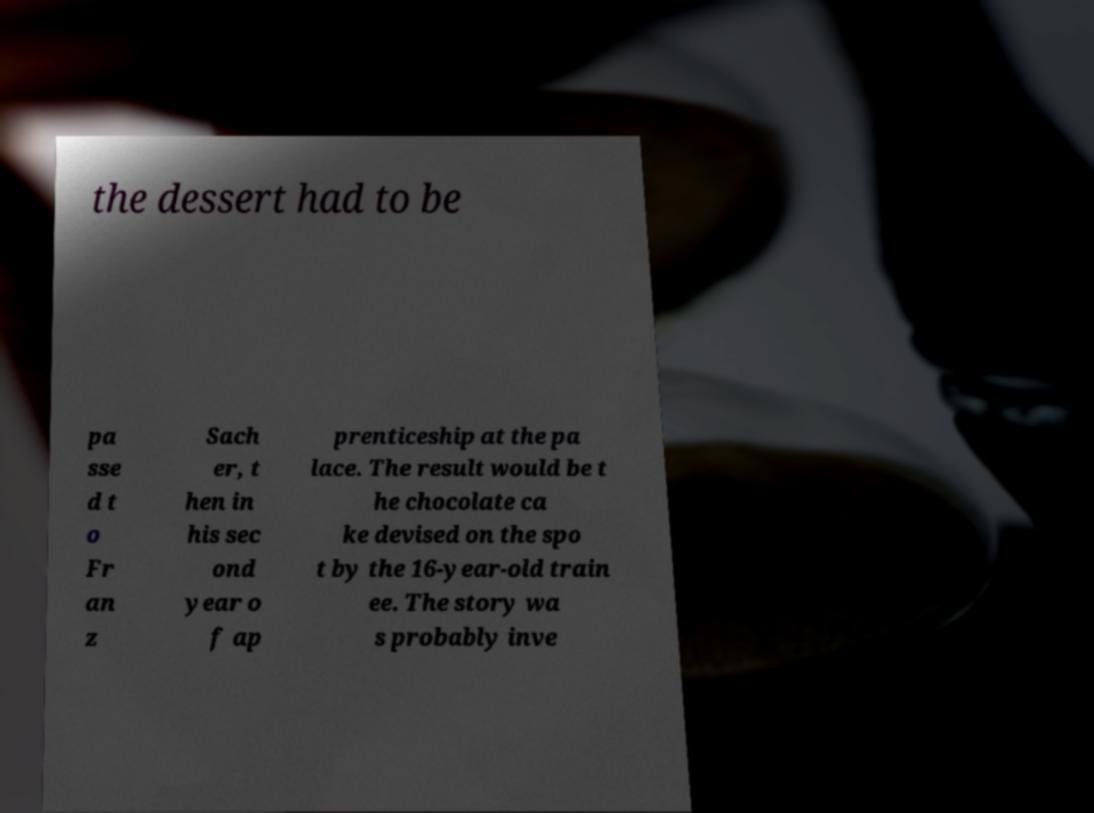Could you assist in decoding the text presented in this image and type it out clearly? the dessert had to be pa sse d t o Fr an z Sach er, t hen in his sec ond year o f ap prenticeship at the pa lace. The result would be t he chocolate ca ke devised on the spo t by the 16-year-old train ee. The story wa s probably inve 